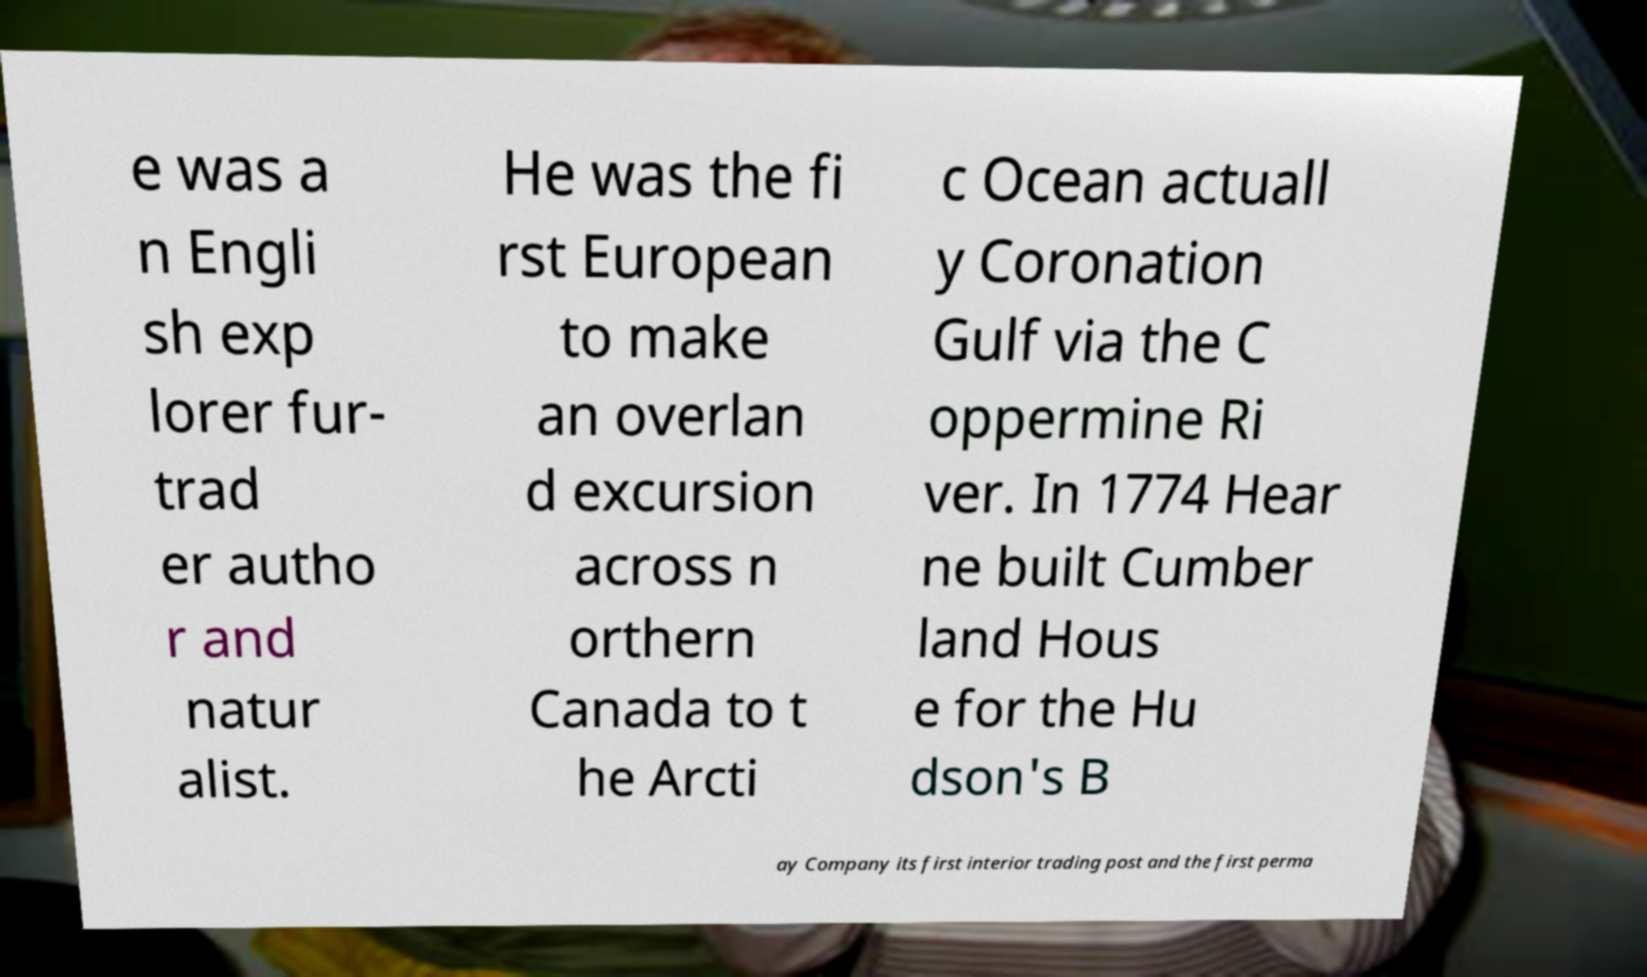What messages or text are displayed in this image? I need them in a readable, typed format. e was a n Engli sh exp lorer fur- trad er autho r and natur alist. He was the fi rst European to make an overlan d excursion across n orthern Canada to t he Arcti c Ocean actuall y Coronation Gulf via the C oppermine Ri ver. In 1774 Hear ne built Cumber land Hous e for the Hu dson's B ay Company its first interior trading post and the first perma 